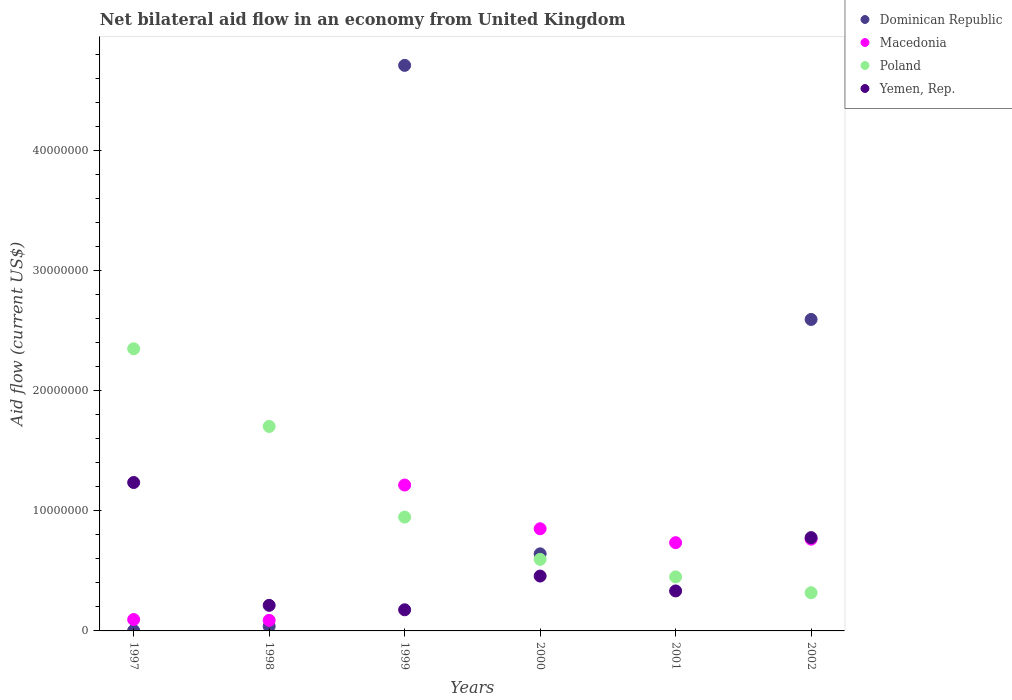Is the number of dotlines equal to the number of legend labels?
Provide a succinct answer. No. What is the net bilateral aid flow in Yemen, Rep. in 2000?
Provide a short and direct response. 4.57e+06. Across all years, what is the maximum net bilateral aid flow in Poland?
Provide a short and direct response. 2.35e+07. Across all years, what is the minimum net bilateral aid flow in Macedonia?
Offer a terse response. 8.80e+05. What is the total net bilateral aid flow in Macedonia in the graph?
Make the answer very short. 3.75e+07. What is the difference between the net bilateral aid flow in Poland in 1998 and that in 2001?
Ensure brevity in your answer.  1.25e+07. What is the difference between the net bilateral aid flow in Poland in 1999 and the net bilateral aid flow in Yemen, Rep. in 2000?
Ensure brevity in your answer.  4.91e+06. What is the average net bilateral aid flow in Poland per year?
Make the answer very short. 1.06e+07. In the year 2002, what is the difference between the net bilateral aid flow in Poland and net bilateral aid flow in Yemen, Rep.?
Give a very brief answer. -4.59e+06. In how many years, is the net bilateral aid flow in Macedonia greater than 24000000 US$?
Offer a terse response. 0. What is the ratio of the net bilateral aid flow in Macedonia in 1999 to that in 2001?
Provide a short and direct response. 1.65. Is the net bilateral aid flow in Dominican Republic in 1997 less than that in 1999?
Make the answer very short. Yes. What is the difference between the highest and the second highest net bilateral aid flow in Dominican Republic?
Keep it short and to the point. 2.12e+07. What is the difference between the highest and the lowest net bilateral aid flow in Yemen, Rep.?
Offer a terse response. 1.06e+07. Is the sum of the net bilateral aid flow in Poland in 1999 and 2001 greater than the maximum net bilateral aid flow in Macedonia across all years?
Offer a very short reply. Yes. Is the net bilateral aid flow in Poland strictly greater than the net bilateral aid flow in Dominican Republic over the years?
Your answer should be very brief. No. Is the net bilateral aid flow in Yemen, Rep. strictly less than the net bilateral aid flow in Dominican Republic over the years?
Ensure brevity in your answer.  No. What is the difference between two consecutive major ticks on the Y-axis?
Offer a very short reply. 1.00e+07. Where does the legend appear in the graph?
Provide a succinct answer. Top right. How many legend labels are there?
Provide a short and direct response. 4. How are the legend labels stacked?
Offer a very short reply. Vertical. What is the title of the graph?
Provide a succinct answer. Net bilateral aid flow in an economy from United Kingdom. Does "Eritrea" appear as one of the legend labels in the graph?
Your answer should be very brief. No. What is the Aid flow (current US$) of Dominican Republic in 1997?
Ensure brevity in your answer.  3.00e+04. What is the Aid flow (current US$) of Macedonia in 1997?
Give a very brief answer. 9.50e+05. What is the Aid flow (current US$) in Poland in 1997?
Your answer should be very brief. 2.35e+07. What is the Aid flow (current US$) of Yemen, Rep. in 1997?
Offer a terse response. 1.24e+07. What is the Aid flow (current US$) of Macedonia in 1998?
Provide a succinct answer. 8.80e+05. What is the Aid flow (current US$) in Poland in 1998?
Keep it short and to the point. 1.70e+07. What is the Aid flow (current US$) in Yemen, Rep. in 1998?
Your response must be concise. 2.13e+06. What is the Aid flow (current US$) in Dominican Republic in 1999?
Your answer should be very brief. 4.71e+07. What is the Aid flow (current US$) of Macedonia in 1999?
Offer a terse response. 1.22e+07. What is the Aid flow (current US$) in Poland in 1999?
Provide a short and direct response. 9.48e+06. What is the Aid flow (current US$) of Yemen, Rep. in 1999?
Ensure brevity in your answer.  1.76e+06. What is the Aid flow (current US$) in Dominican Republic in 2000?
Offer a terse response. 6.42e+06. What is the Aid flow (current US$) of Macedonia in 2000?
Provide a short and direct response. 8.51e+06. What is the Aid flow (current US$) in Poland in 2000?
Give a very brief answer. 5.96e+06. What is the Aid flow (current US$) in Yemen, Rep. in 2000?
Your response must be concise. 4.57e+06. What is the Aid flow (current US$) in Dominican Republic in 2001?
Give a very brief answer. 0. What is the Aid flow (current US$) of Macedonia in 2001?
Give a very brief answer. 7.35e+06. What is the Aid flow (current US$) in Poland in 2001?
Give a very brief answer. 4.50e+06. What is the Aid flow (current US$) of Yemen, Rep. in 2001?
Offer a terse response. 3.33e+06. What is the Aid flow (current US$) of Dominican Republic in 2002?
Offer a very short reply. 2.59e+07. What is the Aid flow (current US$) of Macedonia in 2002?
Offer a very short reply. 7.64e+06. What is the Aid flow (current US$) of Poland in 2002?
Keep it short and to the point. 3.18e+06. What is the Aid flow (current US$) in Yemen, Rep. in 2002?
Give a very brief answer. 7.77e+06. Across all years, what is the maximum Aid flow (current US$) of Dominican Republic?
Offer a terse response. 4.71e+07. Across all years, what is the maximum Aid flow (current US$) of Macedonia?
Provide a short and direct response. 1.22e+07. Across all years, what is the maximum Aid flow (current US$) in Poland?
Keep it short and to the point. 2.35e+07. Across all years, what is the maximum Aid flow (current US$) in Yemen, Rep.?
Offer a very short reply. 1.24e+07. Across all years, what is the minimum Aid flow (current US$) of Macedonia?
Make the answer very short. 8.80e+05. Across all years, what is the minimum Aid flow (current US$) in Poland?
Offer a terse response. 3.18e+06. Across all years, what is the minimum Aid flow (current US$) in Yemen, Rep.?
Offer a terse response. 1.76e+06. What is the total Aid flow (current US$) in Dominican Republic in the graph?
Your answer should be very brief. 7.99e+07. What is the total Aid flow (current US$) of Macedonia in the graph?
Offer a terse response. 3.75e+07. What is the total Aid flow (current US$) of Poland in the graph?
Your answer should be compact. 6.36e+07. What is the total Aid flow (current US$) in Yemen, Rep. in the graph?
Your response must be concise. 3.19e+07. What is the difference between the Aid flow (current US$) of Dominican Republic in 1997 and that in 1998?
Keep it short and to the point. -3.50e+05. What is the difference between the Aid flow (current US$) in Poland in 1997 and that in 1998?
Provide a succinct answer. 6.47e+06. What is the difference between the Aid flow (current US$) of Yemen, Rep. in 1997 and that in 1998?
Offer a terse response. 1.02e+07. What is the difference between the Aid flow (current US$) in Dominican Republic in 1997 and that in 1999?
Give a very brief answer. -4.71e+07. What is the difference between the Aid flow (current US$) in Macedonia in 1997 and that in 1999?
Offer a very short reply. -1.12e+07. What is the difference between the Aid flow (current US$) of Poland in 1997 and that in 1999?
Keep it short and to the point. 1.40e+07. What is the difference between the Aid flow (current US$) of Yemen, Rep. in 1997 and that in 1999?
Offer a terse response. 1.06e+07. What is the difference between the Aid flow (current US$) in Dominican Republic in 1997 and that in 2000?
Make the answer very short. -6.39e+06. What is the difference between the Aid flow (current US$) in Macedonia in 1997 and that in 2000?
Give a very brief answer. -7.56e+06. What is the difference between the Aid flow (current US$) of Poland in 1997 and that in 2000?
Give a very brief answer. 1.75e+07. What is the difference between the Aid flow (current US$) of Yemen, Rep. in 1997 and that in 2000?
Your answer should be compact. 7.79e+06. What is the difference between the Aid flow (current US$) in Macedonia in 1997 and that in 2001?
Ensure brevity in your answer.  -6.40e+06. What is the difference between the Aid flow (current US$) of Poland in 1997 and that in 2001?
Offer a terse response. 1.90e+07. What is the difference between the Aid flow (current US$) of Yemen, Rep. in 1997 and that in 2001?
Your answer should be very brief. 9.03e+06. What is the difference between the Aid flow (current US$) of Dominican Republic in 1997 and that in 2002?
Your answer should be very brief. -2.59e+07. What is the difference between the Aid flow (current US$) in Macedonia in 1997 and that in 2002?
Offer a very short reply. -6.69e+06. What is the difference between the Aid flow (current US$) in Poland in 1997 and that in 2002?
Your response must be concise. 2.03e+07. What is the difference between the Aid flow (current US$) of Yemen, Rep. in 1997 and that in 2002?
Offer a terse response. 4.59e+06. What is the difference between the Aid flow (current US$) in Dominican Republic in 1998 and that in 1999?
Offer a terse response. -4.67e+07. What is the difference between the Aid flow (current US$) of Macedonia in 1998 and that in 1999?
Give a very brief answer. -1.13e+07. What is the difference between the Aid flow (current US$) of Poland in 1998 and that in 1999?
Offer a very short reply. 7.55e+06. What is the difference between the Aid flow (current US$) in Yemen, Rep. in 1998 and that in 1999?
Your answer should be compact. 3.70e+05. What is the difference between the Aid flow (current US$) of Dominican Republic in 1998 and that in 2000?
Give a very brief answer. -6.04e+06. What is the difference between the Aid flow (current US$) in Macedonia in 1998 and that in 2000?
Your answer should be very brief. -7.63e+06. What is the difference between the Aid flow (current US$) in Poland in 1998 and that in 2000?
Your answer should be very brief. 1.11e+07. What is the difference between the Aid flow (current US$) of Yemen, Rep. in 1998 and that in 2000?
Offer a very short reply. -2.44e+06. What is the difference between the Aid flow (current US$) of Macedonia in 1998 and that in 2001?
Give a very brief answer. -6.47e+06. What is the difference between the Aid flow (current US$) of Poland in 1998 and that in 2001?
Offer a very short reply. 1.25e+07. What is the difference between the Aid flow (current US$) of Yemen, Rep. in 1998 and that in 2001?
Keep it short and to the point. -1.20e+06. What is the difference between the Aid flow (current US$) of Dominican Republic in 1998 and that in 2002?
Your answer should be very brief. -2.56e+07. What is the difference between the Aid flow (current US$) of Macedonia in 1998 and that in 2002?
Your response must be concise. -6.76e+06. What is the difference between the Aid flow (current US$) in Poland in 1998 and that in 2002?
Offer a terse response. 1.38e+07. What is the difference between the Aid flow (current US$) of Yemen, Rep. in 1998 and that in 2002?
Make the answer very short. -5.64e+06. What is the difference between the Aid flow (current US$) of Dominican Republic in 1999 and that in 2000?
Your answer should be very brief. 4.07e+07. What is the difference between the Aid flow (current US$) of Macedonia in 1999 and that in 2000?
Make the answer very short. 3.64e+06. What is the difference between the Aid flow (current US$) of Poland in 1999 and that in 2000?
Provide a short and direct response. 3.52e+06. What is the difference between the Aid flow (current US$) in Yemen, Rep. in 1999 and that in 2000?
Provide a short and direct response. -2.81e+06. What is the difference between the Aid flow (current US$) of Macedonia in 1999 and that in 2001?
Give a very brief answer. 4.80e+06. What is the difference between the Aid flow (current US$) of Poland in 1999 and that in 2001?
Keep it short and to the point. 4.98e+06. What is the difference between the Aid flow (current US$) in Yemen, Rep. in 1999 and that in 2001?
Ensure brevity in your answer.  -1.57e+06. What is the difference between the Aid flow (current US$) of Dominican Republic in 1999 and that in 2002?
Provide a short and direct response. 2.12e+07. What is the difference between the Aid flow (current US$) in Macedonia in 1999 and that in 2002?
Provide a succinct answer. 4.51e+06. What is the difference between the Aid flow (current US$) in Poland in 1999 and that in 2002?
Keep it short and to the point. 6.30e+06. What is the difference between the Aid flow (current US$) in Yemen, Rep. in 1999 and that in 2002?
Keep it short and to the point. -6.01e+06. What is the difference between the Aid flow (current US$) of Macedonia in 2000 and that in 2001?
Ensure brevity in your answer.  1.16e+06. What is the difference between the Aid flow (current US$) of Poland in 2000 and that in 2001?
Offer a very short reply. 1.46e+06. What is the difference between the Aid flow (current US$) in Yemen, Rep. in 2000 and that in 2001?
Provide a short and direct response. 1.24e+06. What is the difference between the Aid flow (current US$) in Dominican Republic in 2000 and that in 2002?
Keep it short and to the point. -1.95e+07. What is the difference between the Aid flow (current US$) in Macedonia in 2000 and that in 2002?
Make the answer very short. 8.70e+05. What is the difference between the Aid flow (current US$) of Poland in 2000 and that in 2002?
Offer a very short reply. 2.78e+06. What is the difference between the Aid flow (current US$) of Yemen, Rep. in 2000 and that in 2002?
Ensure brevity in your answer.  -3.20e+06. What is the difference between the Aid flow (current US$) in Poland in 2001 and that in 2002?
Give a very brief answer. 1.32e+06. What is the difference between the Aid flow (current US$) in Yemen, Rep. in 2001 and that in 2002?
Make the answer very short. -4.44e+06. What is the difference between the Aid flow (current US$) in Dominican Republic in 1997 and the Aid flow (current US$) in Macedonia in 1998?
Your answer should be compact. -8.50e+05. What is the difference between the Aid flow (current US$) of Dominican Republic in 1997 and the Aid flow (current US$) of Poland in 1998?
Ensure brevity in your answer.  -1.70e+07. What is the difference between the Aid flow (current US$) in Dominican Republic in 1997 and the Aid flow (current US$) in Yemen, Rep. in 1998?
Offer a very short reply. -2.10e+06. What is the difference between the Aid flow (current US$) in Macedonia in 1997 and the Aid flow (current US$) in Poland in 1998?
Offer a very short reply. -1.61e+07. What is the difference between the Aid flow (current US$) in Macedonia in 1997 and the Aid flow (current US$) in Yemen, Rep. in 1998?
Offer a terse response. -1.18e+06. What is the difference between the Aid flow (current US$) in Poland in 1997 and the Aid flow (current US$) in Yemen, Rep. in 1998?
Provide a succinct answer. 2.14e+07. What is the difference between the Aid flow (current US$) in Dominican Republic in 1997 and the Aid flow (current US$) in Macedonia in 1999?
Your response must be concise. -1.21e+07. What is the difference between the Aid flow (current US$) of Dominican Republic in 1997 and the Aid flow (current US$) of Poland in 1999?
Your response must be concise. -9.45e+06. What is the difference between the Aid flow (current US$) in Dominican Republic in 1997 and the Aid flow (current US$) in Yemen, Rep. in 1999?
Give a very brief answer. -1.73e+06. What is the difference between the Aid flow (current US$) of Macedonia in 1997 and the Aid flow (current US$) of Poland in 1999?
Keep it short and to the point. -8.53e+06. What is the difference between the Aid flow (current US$) of Macedonia in 1997 and the Aid flow (current US$) of Yemen, Rep. in 1999?
Give a very brief answer. -8.10e+05. What is the difference between the Aid flow (current US$) in Poland in 1997 and the Aid flow (current US$) in Yemen, Rep. in 1999?
Make the answer very short. 2.17e+07. What is the difference between the Aid flow (current US$) of Dominican Republic in 1997 and the Aid flow (current US$) of Macedonia in 2000?
Offer a terse response. -8.48e+06. What is the difference between the Aid flow (current US$) in Dominican Republic in 1997 and the Aid flow (current US$) in Poland in 2000?
Give a very brief answer. -5.93e+06. What is the difference between the Aid flow (current US$) of Dominican Republic in 1997 and the Aid flow (current US$) of Yemen, Rep. in 2000?
Give a very brief answer. -4.54e+06. What is the difference between the Aid flow (current US$) of Macedonia in 1997 and the Aid flow (current US$) of Poland in 2000?
Ensure brevity in your answer.  -5.01e+06. What is the difference between the Aid flow (current US$) of Macedonia in 1997 and the Aid flow (current US$) of Yemen, Rep. in 2000?
Offer a terse response. -3.62e+06. What is the difference between the Aid flow (current US$) in Poland in 1997 and the Aid flow (current US$) in Yemen, Rep. in 2000?
Your response must be concise. 1.89e+07. What is the difference between the Aid flow (current US$) of Dominican Republic in 1997 and the Aid flow (current US$) of Macedonia in 2001?
Make the answer very short. -7.32e+06. What is the difference between the Aid flow (current US$) in Dominican Republic in 1997 and the Aid flow (current US$) in Poland in 2001?
Your answer should be very brief. -4.47e+06. What is the difference between the Aid flow (current US$) of Dominican Republic in 1997 and the Aid flow (current US$) of Yemen, Rep. in 2001?
Your answer should be compact. -3.30e+06. What is the difference between the Aid flow (current US$) in Macedonia in 1997 and the Aid flow (current US$) in Poland in 2001?
Keep it short and to the point. -3.55e+06. What is the difference between the Aid flow (current US$) of Macedonia in 1997 and the Aid flow (current US$) of Yemen, Rep. in 2001?
Your answer should be compact. -2.38e+06. What is the difference between the Aid flow (current US$) of Poland in 1997 and the Aid flow (current US$) of Yemen, Rep. in 2001?
Your response must be concise. 2.02e+07. What is the difference between the Aid flow (current US$) of Dominican Republic in 1997 and the Aid flow (current US$) of Macedonia in 2002?
Give a very brief answer. -7.61e+06. What is the difference between the Aid flow (current US$) of Dominican Republic in 1997 and the Aid flow (current US$) of Poland in 2002?
Provide a short and direct response. -3.15e+06. What is the difference between the Aid flow (current US$) in Dominican Republic in 1997 and the Aid flow (current US$) in Yemen, Rep. in 2002?
Ensure brevity in your answer.  -7.74e+06. What is the difference between the Aid flow (current US$) of Macedonia in 1997 and the Aid flow (current US$) of Poland in 2002?
Your answer should be compact. -2.23e+06. What is the difference between the Aid flow (current US$) in Macedonia in 1997 and the Aid flow (current US$) in Yemen, Rep. in 2002?
Keep it short and to the point. -6.82e+06. What is the difference between the Aid flow (current US$) of Poland in 1997 and the Aid flow (current US$) of Yemen, Rep. in 2002?
Your response must be concise. 1.57e+07. What is the difference between the Aid flow (current US$) of Dominican Republic in 1998 and the Aid flow (current US$) of Macedonia in 1999?
Your answer should be compact. -1.18e+07. What is the difference between the Aid flow (current US$) in Dominican Republic in 1998 and the Aid flow (current US$) in Poland in 1999?
Ensure brevity in your answer.  -9.10e+06. What is the difference between the Aid flow (current US$) in Dominican Republic in 1998 and the Aid flow (current US$) in Yemen, Rep. in 1999?
Give a very brief answer. -1.38e+06. What is the difference between the Aid flow (current US$) in Macedonia in 1998 and the Aid flow (current US$) in Poland in 1999?
Your response must be concise. -8.60e+06. What is the difference between the Aid flow (current US$) of Macedonia in 1998 and the Aid flow (current US$) of Yemen, Rep. in 1999?
Your response must be concise. -8.80e+05. What is the difference between the Aid flow (current US$) in Poland in 1998 and the Aid flow (current US$) in Yemen, Rep. in 1999?
Provide a succinct answer. 1.53e+07. What is the difference between the Aid flow (current US$) of Dominican Republic in 1998 and the Aid flow (current US$) of Macedonia in 2000?
Your response must be concise. -8.13e+06. What is the difference between the Aid flow (current US$) of Dominican Republic in 1998 and the Aid flow (current US$) of Poland in 2000?
Your answer should be very brief. -5.58e+06. What is the difference between the Aid flow (current US$) of Dominican Republic in 1998 and the Aid flow (current US$) of Yemen, Rep. in 2000?
Ensure brevity in your answer.  -4.19e+06. What is the difference between the Aid flow (current US$) of Macedonia in 1998 and the Aid flow (current US$) of Poland in 2000?
Provide a short and direct response. -5.08e+06. What is the difference between the Aid flow (current US$) in Macedonia in 1998 and the Aid flow (current US$) in Yemen, Rep. in 2000?
Provide a short and direct response. -3.69e+06. What is the difference between the Aid flow (current US$) of Poland in 1998 and the Aid flow (current US$) of Yemen, Rep. in 2000?
Provide a succinct answer. 1.25e+07. What is the difference between the Aid flow (current US$) of Dominican Republic in 1998 and the Aid flow (current US$) of Macedonia in 2001?
Your response must be concise. -6.97e+06. What is the difference between the Aid flow (current US$) in Dominican Republic in 1998 and the Aid flow (current US$) in Poland in 2001?
Ensure brevity in your answer.  -4.12e+06. What is the difference between the Aid flow (current US$) of Dominican Republic in 1998 and the Aid flow (current US$) of Yemen, Rep. in 2001?
Your answer should be compact. -2.95e+06. What is the difference between the Aid flow (current US$) in Macedonia in 1998 and the Aid flow (current US$) in Poland in 2001?
Offer a terse response. -3.62e+06. What is the difference between the Aid flow (current US$) of Macedonia in 1998 and the Aid flow (current US$) of Yemen, Rep. in 2001?
Keep it short and to the point. -2.45e+06. What is the difference between the Aid flow (current US$) of Poland in 1998 and the Aid flow (current US$) of Yemen, Rep. in 2001?
Your answer should be compact. 1.37e+07. What is the difference between the Aid flow (current US$) in Dominican Republic in 1998 and the Aid flow (current US$) in Macedonia in 2002?
Your answer should be compact. -7.26e+06. What is the difference between the Aid flow (current US$) of Dominican Republic in 1998 and the Aid flow (current US$) of Poland in 2002?
Your answer should be compact. -2.80e+06. What is the difference between the Aid flow (current US$) in Dominican Republic in 1998 and the Aid flow (current US$) in Yemen, Rep. in 2002?
Provide a succinct answer. -7.39e+06. What is the difference between the Aid flow (current US$) in Macedonia in 1998 and the Aid flow (current US$) in Poland in 2002?
Your answer should be compact. -2.30e+06. What is the difference between the Aid flow (current US$) of Macedonia in 1998 and the Aid flow (current US$) of Yemen, Rep. in 2002?
Your answer should be compact. -6.89e+06. What is the difference between the Aid flow (current US$) in Poland in 1998 and the Aid flow (current US$) in Yemen, Rep. in 2002?
Provide a short and direct response. 9.26e+06. What is the difference between the Aid flow (current US$) of Dominican Republic in 1999 and the Aid flow (current US$) of Macedonia in 2000?
Make the answer very short. 3.86e+07. What is the difference between the Aid flow (current US$) in Dominican Republic in 1999 and the Aid flow (current US$) in Poland in 2000?
Keep it short and to the point. 4.11e+07. What is the difference between the Aid flow (current US$) in Dominican Republic in 1999 and the Aid flow (current US$) in Yemen, Rep. in 2000?
Provide a succinct answer. 4.25e+07. What is the difference between the Aid flow (current US$) in Macedonia in 1999 and the Aid flow (current US$) in Poland in 2000?
Provide a succinct answer. 6.19e+06. What is the difference between the Aid flow (current US$) in Macedonia in 1999 and the Aid flow (current US$) in Yemen, Rep. in 2000?
Your response must be concise. 7.58e+06. What is the difference between the Aid flow (current US$) in Poland in 1999 and the Aid flow (current US$) in Yemen, Rep. in 2000?
Offer a terse response. 4.91e+06. What is the difference between the Aid flow (current US$) of Dominican Republic in 1999 and the Aid flow (current US$) of Macedonia in 2001?
Ensure brevity in your answer.  3.98e+07. What is the difference between the Aid flow (current US$) of Dominican Republic in 1999 and the Aid flow (current US$) of Poland in 2001?
Your answer should be compact. 4.26e+07. What is the difference between the Aid flow (current US$) in Dominican Republic in 1999 and the Aid flow (current US$) in Yemen, Rep. in 2001?
Provide a succinct answer. 4.38e+07. What is the difference between the Aid flow (current US$) in Macedonia in 1999 and the Aid flow (current US$) in Poland in 2001?
Ensure brevity in your answer.  7.65e+06. What is the difference between the Aid flow (current US$) in Macedonia in 1999 and the Aid flow (current US$) in Yemen, Rep. in 2001?
Keep it short and to the point. 8.82e+06. What is the difference between the Aid flow (current US$) of Poland in 1999 and the Aid flow (current US$) of Yemen, Rep. in 2001?
Ensure brevity in your answer.  6.15e+06. What is the difference between the Aid flow (current US$) of Dominican Republic in 1999 and the Aid flow (current US$) of Macedonia in 2002?
Ensure brevity in your answer.  3.95e+07. What is the difference between the Aid flow (current US$) in Dominican Republic in 1999 and the Aid flow (current US$) in Poland in 2002?
Offer a very short reply. 4.39e+07. What is the difference between the Aid flow (current US$) of Dominican Republic in 1999 and the Aid flow (current US$) of Yemen, Rep. in 2002?
Your answer should be very brief. 3.93e+07. What is the difference between the Aid flow (current US$) in Macedonia in 1999 and the Aid flow (current US$) in Poland in 2002?
Make the answer very short. 8.97e+06. What is the difference between the Aid flow (current US$) of Macedonia in 1999 and the Aid flow (current US$) of Yemen, Rep. in 2002?
Give a very brief answer. 4.38e+06. What is the difference between the Aid flow (current US$) in Poland in 1999 and the Aid flow (current US$) in Yemen, Rep. in 2002?
Offer a very short reply. 1.71e+06. What is the difference between the Aid flow (current US$) of Dominican Republic in 2000 and the Aid flow (current US$) of Macedonia in 2001?
Make the answer very short. -9.30e+05. What is the difference between the Aid flow (current US$) of Dominican Republic in 2000 and the Aid flow (current US$) of Poland in 2001?
Your answer should be very brief. 1.92e+06. What is the difference between the Aid flow (current US$) in Dominican Republic in 2000 and the Aid flow (current US$) in Yemen, Rep. in 2001?
Ensure brevity in your answer.  3.09e+06. What is the difference between the Aid flow (current US$) in Macedonia in 2000 and the Aid flow (current US$) in Poland in 2001?
Provide a short and direct response. 4.01e+06. What is the difference between the Aid flow (current US$) in Macedonia in 2000 and the Aid flow (current US$) in Yemen, Rep. in 2001?
Your response must be concise. 5.18e+06. What is the difference between the Aid flow (current US$) in Poland in 2000 and the Aid flow (current US$) in Yemen, Rep. in 2001?
Provide a succinct answer. 2.63e+06. What is the difference between the Aid flow (current US$) of Dominican Republic in 2000 and the Aid flow (current US$) of Macedonia in 2002?
Your response must be concise. -1.22e+06. What is the difference between the Aid flow (current US$) of Dominican Republic in 2000 and the Aid flow (current US$) of Poland in 2002?
Keep it short and to the point. 3.24e+06. What is the difference between the Aid flow (current US$) of Dominican Republic in 2000 and the Aid flow (current US$) of Yemen, Rep. in 2002?
Offer a very short reply. -1.35e+06. What is the difference between the Aid flow (current US$) in Macedonia in 2000 and the Aid flow (current US$) in Poland in 2002?
Your answer should be compact. 5.33e+06. What is the difference between the Aid flow (current US$) of Macedonia in 2000 and the Aid flow (current US$) of Yemen, Rep. in 2002?
Offer a very short reply. 7.40e+05. What is the difference between the Aid flow (current US$) of Poland in 2000 and the Aid flow (current US$) of Yemen, Rep. in 2002?
Ensure brevity in your answer.  -1.81e+06. What is the difference between the Aid flow (current US$) of Macedonia in 2001 and the Aid flow (current US$) of Poland in 2002?
Ensure brevity in your answer.  4.17e+06. What is the difference between the Aid flow (current US$) of Macedonia in 2001 and the Aid flow (current US$) of Yemen, Rep. in 2002?
Make the answer very short. -4.20e+05. What is the difference between the Aid flow (current US$) in Poland in 2001 and the Aid flow (current US$) in Yemen, Rep. in 2002?
Provide a succinct answer. -3.27e+06. What is the average Aid flow (current US$) of Dominican Republic per year?
Offer a very short reply. 1.33e+07. What is the average Aid flow (current US$) in Macedonia per year?
Provide a succinct answer. 6.25e+06. What is the average Aid flow (current US$) in Poland per year?
Your response must be concise. 1.06e+07. What is the average Aid flow (current US$) in Yemen, Rep. per year?
Your response must be concise. 5.32e+06. In the year 1997, what is the difference between the Aid flow (current US$) in Dominican Republic and Aid flow (current US$) in Macedonia?
Give a very brief answer. -9.20e+05. In the year 1997, what is the difference between the Aid flow (current US$) in Dominican Republic and Aid flow (current US$) in Poland?
Give a very brief answer. -2.35e+07. In the year 1997, what is the difference between the Aid flow (current US$) of Dominican Republic and Aid flow (current US$) of Yemen, Rep.?
Provide a short and direct response. -1.23e+07. In the year 1997, what is the difference between the Aid flow (current US$) in Macedonia and Aid flow (current US$) in Poland?
Your answer should be very brief. -2.26e+07. In the year 1997, what is the difference between the Aid flow (current US$) in Macedonia and Aid flow (current US$) in Yemen, Rep.?
Your answer should be compact. -1.14e+07. In the year 1997, what is the difference between the Aid flow (current US$) of Poland and Aid flow (current US$) of Yemen, Rep.?
Offer a terse response. 1.11e+07. In the year 1998, what is the difference between the Aid flow (current US$) of Dominican Republic and Aid flow (current US$) of Macedonia?
Offer a terse response. -5.00e+05. In the year 1998, what is the difference between the Aid flow (current US$) in Dominican Republic and Aid flow (current US$) in Poland?
Your answer should be very brief. -1.66e+07. In the year 1998, what is the difference between the Aid flow (current US$) in Dominican Republic and Aid flow (current US$) in Yemen, Rep.?
Your answer should be compact. -1.75e+06. In the year 1998, what is the difference between the Aid flow (current US$) of Macedonia and Aid flow (current US$) of Poland?
Make the answer very short. -1.62e+07. In the year 1998, what is the difference between the Aid flow (current US$) of Macedonia and Aid flow (current US$) of Yemen, Rep.?
Your answer should be very brief. -1.25e+06. In the year 1998, what is the difference between the Aid flow (current US$) of Poland and Aid flow (current US$) of Yemen, Rep.?
Offer a terse response. 1.49e+07. In the year 1999, what is the difference between the Aid flow (current US$) in Dominican Republic and Aid flow (current US$) in Macedonia?
Offer a very short reply. 3.50e+07. In the year 1999, what is the difference between the Aid flow (current US$) in Dominican Republic and Aid flow (current US$) in Poland?
Offer a terse response. 3.76e+07. In the year 1999, what is the difference between the Aid flow (current US$) of Dominican Republic and Aid flow (current US$) of Yemen, Rep.?
Offer a very short reply. 4.53e+07. In the year 1999, what is the difference between the Aid flow (current US$) in Macedonia and Aid flow (current US$) in Poland?
Provide a short and direct response. 2.67e+06. In the year 1999, what is the difference between the Aid flow (current US$) in Macedonia and Aid flow (current US$) in Yemen, Rep.?
Keep it short and to the point. 1.04e+07. In the year 1999, what is the difference between the Aid flow (current US$) of Poland and Aid flow (current US$) of Yemen, Rep.?
Your response must be concise. 7.72e+06. In the year 2000, what is the difference between the Aid flow (current US$) in Dominican Republic and Aid flow (current US$) in Macedonia?
Keep it short and to the point. -2.09e+06. In the year 2000, what is the difference between the Aid flow (current US$) of Dominican Republic and Aid flow (current US$) of Yemen, Rep.?
Offer a terse response. 1.85e+06. In the year 2000, what is the difference between the Aid flow (current US$) in Macedonia and Aid flow (current US$) in Poland?
Ensure brevity in your answer.  2.55e+06. In the year 2000, what is the difference between the Aid flow (current US$) in Macedonia and Aid flow (current US$) in Yemen, Rep.?
Offer a terse response. 3.94e+06. In the year 2000, what is the difference between the Aid flow (current US$) in Poland and Aid flow (current US$) in Yemen, Rep.?
Offer a very short reply. 1.39e+06. In the year 2001, what is the difference between the Aid flow (current US$) of Macedonia and Aid flow (current US$) of Poland?
Provide a short and direct response. 2.85e+06. In the year 2001, what is the difference between the Aid flow (current US$) of Macedonia and Aid flow (current US$) of Yemen, Rep.?
Your answer should be compact. 4.02e+06. In the year 2001, what is the difference between the Aid flow (current US$) in Poland and Aid flow (current US$) in Yemen, Rep.?
Offer a terse response. 1.17e+06. In the year 2002, what is the difference between the Aid flow (current US$) in Dominican Republic and Aid flow (current US$) in Macedonia?
Your response must be concise. 1.83e+07. In the year 2002, what is the difference between the Aid flow (current US$) in Dominican Republic and Aid flow (current US$) in Poland?
Provide a succinct answer. 2.28e+07. In the year 2002, what is the difference between the Aid flow (current US$) of Dominican Republic and Aid flow (current US$) of Yemen, Rep.?
Give a very brief answer. 1.82e+07. In the year 2002, what is the difference between the Aid flow (current US$) in Macedonia and Aid flow (current US$) in Poland?
Your answer should be compact. 4.46e+06. In the year 2002, what is the difference between the Aid flow (current US$) in Macedonia and Aid flow (current US$) in Yemen, Rep.?
Your answer should be very brief. -1.30e+05. In the year 2002, what is the difference between the Aid flow (current US$) in Poland and Aid flow (current US$) in Yemen, Rep.?
Your response must be concise. -4.59e+06. What is the ratio of the Aid flow (current US$) in Dominican Republic in 1997 to that in 1998?
Ensure brevity in your answer.  0.08. What is the ratio of the Aid flow (current US$) of Macedonia in 1997 to that in 1998?
Offer a very short reply. 1.08. What is the ratio of the Aid flow (current US$) in Poland in 1997 to that in 1998?
Provide a short and direct response. 1.38. What is the ratio of the Aid flow (current US$) in Yemen, Rep. in 1997 to that in 1998?
Ensure brevity in your answer.  5.8. What is the ratio of the Aid flow (current US$) of Dominican Republic in 1997 to that in 1999?
Provide a succinct answer. 0. What is the ratio of the Aid flow (current US$) in Macedonia in 1997 to that in 1999?
Your answer should be compact. 0.08. What is the ratio of the Aid flow (current US$) of Poland in 1997 to that in 1999?
Provide a succinct answer. 2.48. What is the ratio of the Aid flow (current US$) of Yemen, Rep. in 1997 to that in 1999?
Your answer should be compact. 7.02. What is the ratio of the Aid flow (current US$) of Dominican Republic in 1997 to that in 2000?
Provide a succinct answer. 0. What is the ratio of the Aid flow (current US$) of Macedonia in 1997 to that in 2000?
Give a very brief answer. 0.11. What is the ratio of the Aid flow (current US$) of Poland in 1997 to that in 2000?
Ensure brevity in your answer.  3.94. What is the ratio of the Aid flow (current US$) of Yemen, Rep. in 1997 to that in 2000?
Your answer should be very brief. 2.7. What is the ratio of the Aid flow (current US$) of Macedonia in 1997 to that in 2001?
Your response must be concise. 0.13. What is the ratio of the Aid flow (current US$) of Poland in 1997 to that in 2001?
Make the answer very short. 5.22. What is the ratio of the Aid flow (current US$) of Yemen, Rep. in 1997 to that in 2001?
Offer a terse response. 3.71. What is the ratio of the Aid flow (current US$) in Dominican Republic in 1997 to that in 2002?
Your answer should be very brief. 0. What is the ratio of the Aid flow (current US$) in Macedonia in 1997 to that in 2002?
Your answer should be compact. 0.12. What is the ratio of the Aid flow (current US$) in Poland in 1997 to that in 2002?
Provide a short and direct response. 7.39. What is the ratio of the Aid flow (current US$) of Yemen, Rep. in 1997 to that in 2002?
Your response must be concise. 1.59. What is the ratio of the Aid flow (current US$) of Dominican Republic in 1998 to that in 1999?
Ensure brevity in your answer.  0.01. What is the ratio of the Aid flow (current US$) in Macedonia in 1998 to that in 1999?
Your answer should be very brief. 0.07. What is the ratio of the Aid flow (current US$) of Poland in 1998 to that in 1999?
Offer a very short reply. 1.8. What is the ratio of the Aid flow (current US$) in Yemen, Rep. in 1998 to that in 1999?
Ensure brevity in your answer.  1.21. What is the ratio of the Aid flow (current US$) of Dominican Republic in 1998 to that in 2000?
Offer a very short reply. 0.06. What is the ratio of the Aid flow (current US$) in Macedonia in 1998 to that in 2000?
Make the answer very short. 0.1. What is the ratio of the Aid flow (current US$) of Poland in 1998 to that in 2000?
Your response must be concise. 2.86. What is the ratio of the Aid flow (current US$) in Yemen, Rep. in 1998 to that in 2000?
Your answer should be compact. 0.47. What is the ratio of the Aid flow (current US$) in Macedonia in 1998 to that in 2001?
Keep it short and to the point. 0.12. What is the ratio of the Aid flow (current US$) in Poland in 1998 to that in 2001?
Make the answer very short. 3.78. What is the ratio of the Aid flow (current US$) in Yemen, Rep. in 1998 to that in 2001?
Your answer should be compact. 0.64. What is the ratio of the Aid flow (current US$) in Dominican Republic in 1998 to that in 2002?
Make the answer very short. 0.01. What is the ratio of the Aid flow (current US$) in Macedonia in 1998 to that in 2002?
Give a very brief answer. 0.12. What is the ratio of the Aid flow (current US$) of Poland in 1998 to that in 2002?
Provide a succinct answer. 5.36. What is the ratio of the Aid flow (current US$) of Yemen, Rep. in 1998 to that in 2002?
Your answer should be very brief. 0.27. What is the ratio of the Aid flow (current US$) in Dominican Republic in 1999 to that in 2000?
Your response must be concise. 7.34. What is the ratio of the Aid flow (current US$) of Macedonia in 1999 to that in 2000?
Your answer should be compact. 1.43. What is the ratio of the Aid flow (current US$) of Poland in 1999 to that in 2000?
Your response must be concise. 1.59. What is the ratio of the Aid flow (current US$) of Yemen, Rep. in 1999 to that in 2000?
Make the answer very short. 0.39. What is the ratio of the Aid flow (current US$) in Macedonia in 1999 to that in 2001?
Keep it short and to the point. 1.65. What is the ratio of the Aid flow (current US$) of Poland in 1999 to that in 2001?
Provide a succinct answer. 2.11. What is the ratio of the Aid flow (current US$) in Yemen, Rep. in 1999 to that in 2001?
Provide a short and direct response. 0.53. What is the ratio of the Aid flow (current US$) in Dominican Republic in 1999 to that in 2002?
Keep it short and to the point. 1.82. What is the ratio of the Aid flow (current US$) of Macedonia in 1999 to that in 2002?
Your answer should be very brief. 1.59. What is the ratio of the Aid flow (current US$) of Poland in 1999 to that in 2002?
Ensure brevity in your answer.  2.98. What is the ratio of the Aid flow (current US$) of Yemen, Rep. in 1999 to that in 2002?
Keep it short and to the point. 0.23. What is the ratio of the Aid flow (current US$) of Macedonia in 2000 to that in 2001?
Give a very brief answer. 1.16. What is the ratio of the Aid flow (current US$) of Poland in 2000 to that in 2001?
Your answer should be very brief. 1.32. What is the ratio of the Aid flow (current US$) in Yemen, Rep. in 2000 to that in 2001?
Provide a succinct answer. 1.37. What is the ratio of the Aid flow (current US$) of Dominican Republic in 2000 to that in 2002?
Your response must be concise. 0.25. What is the ratio of the Aid flow (current US$) in Macedonia in 2000 to that in 2002?
Make the answer very short. 1.11. What is the ratio of the Aid flow (current US$) in Poland in 2000 to that in 2002?
Provide a succinct answer. 1.87. What is the ratio of the Aid flow (current US$) of Yemen, Rep. in 2000 to that in 2002?
Offer a very short reply. 0.59. What is the ratio of the Aid flow (current US$) of Poland in 2001 to that in 2002?
Offer a terse response. 1.42. What is the ratio of the Aid flow (current US$) of Yemen, Rep. in 2001 to that in 2002?
Ensure brevity in your answer.  0.43. What is the difference between the highest and the second highest Aid flow (current US$) in Dominican Republic?
Offer a very short reply. 2.12e+07. What is the difference between the highest and the second highest Aid flow (current US$) in Macedonia?
Keep it short and to the point. 3.64e+06. What is the difference between the highest and the second highest Aid flow (current US$) of Poland?
Give a very brief answer. 6.47e+06. What is the difference between the highest and the second highest Aid flow (current US$) in Yemen, Rep.?
Give a very brief answer. 4.59e+06. What is the difference between the highest and the lowest Aid flow (current US$) in Dominican Republic?
Give a very brief answer. 4.71e+07. What is the difference between the highest and the lowest Aid flow (current US$) of Macedonia?
Offer a very short reply. 1.13e+07. What is the difference between the highest and the lowest Aid flow (current US$) of Poland?
Provide a short and direct response. 2.03e+07. What is the difference between the highest and the lowest Aid flow (current US$) in Yemen, Rep.?
Offer a very short reply. 1.06e+07. 